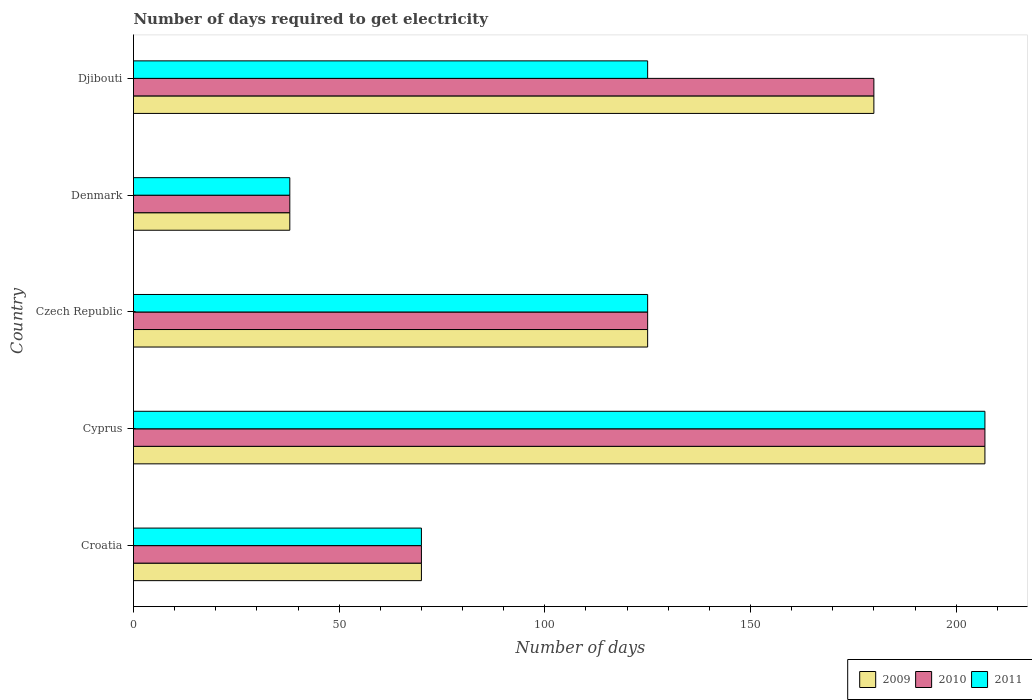How many groups of bars are there?
Provide a succinct answer. 5. How many bars are there on the 5th tick from the top?
Make the answer very short. 3. How many bars are there on the 1st tick from the bottom?
Provide a short and direct response. 3. What is the label of the 4th group of bars from the top?
Your answer should be very brief. Cyprus. What is the number of days required to get electricity in in 2010 in Cyprus?
Your response must be concise. 207. Across all countries, what is the maximum number of days required to get electricity in in 2010?
Make the answer very short. 207. Across all countries, what is the minimum number of days required to get electricity in in 2009?
Ensure brevity in your answer.  38. In which country was the number of days required to get electricity in in 2010 maximum?
Provide a succinct answer. Cyprus. What is the total number of days required to get electricity in in 2009 in the graph?
Make the answer very short. 620. What is the difference between the number of days required to get electricity in in 2009 in Croatia and that in Czech Republic?
Ensure brevity in your answer.  -55. What is the difference between the number of days required to get electricity in in 2010 in Djibouti and the number of days required to get electricity in in 2009 in Cyprus?
Offer a very short reply. -27. What is the average number of days required to get electricity in in 2011 per country?
Make the answer very short. 113. What is the difference between the number of days required to get electricity in in 2011 and number of days required to get electricity in in 2009 in Cyprus?
Give a very brief answer. 0. In how many countries, is the number of days required to get electricity in in 2009 greater than 110 days?
Offer a very short reply. 3. What is the ratio of the number of days required to get electricity in in 2010 in Croatia to that in Djibouti?
Give a very brief answer. 0.39. What is the difference between the highest and the second highest number of days required to get electricity in in 2009?
Keep it short and to the point. 27. What is the difference between the highest and the lowest number of days required to get electricity in in 2009?
Keep it short and to the point. 169. In how many countries, is the number of days required to get electricity in in 2011 greater than the average number of days required to get electricity in in 2011 taken over all countries?
Your answer should be compact. 3. Is the sum of the number of days required to get electricity in in 2011 in Cyprus and Denmark greater than the maximum number of days required to get electricity in in 2010 across all countries?
Make the answer very short. Yes. What does the 2nd bar from the top in Denmark represents?
Your answer should be compact. 2010. Is it the case that in every country, the sum of the number of days required to get electricity in in 2009 and number of days required to get electricity in in 2011 is greater than the number of days required to get electricity in in 2010?
Provide a succinct answer. Yes. How many bars are there?
Make the answer very short. 15. How many countries are there in the graph?
Make the answer very short. 5. Are the values on the major ticks of X-axis written in scientific E-notation?
Offer a terse response. No. Where does the legend appear in the graph?
Your response must be concise. Bottom right. How many legend labels are there?
Provide a short and direct response. 3. What is the title of the graph?
Give a very brief answer. Number of days required to get electricity. What is the label or title of the X-axis?
Keep it short and to the point. Number of days. What is the Number of days in 2010 in Croatia?
Make the answer very short. 70. What is the Number of days of 2011 in Croatia?
Your response must be concise. 70. What is the Number of days of 2009 in Cyprus?
Keep it short and to the point. 207. What is the Number of days in 2010 in Cyprus?
Make the answer very short. 207. What is the Number of days in 2011 in Cyprus?
Your answer should be compact. 207. What is the Number of days in 2009 in Czech Republic?
Give a very brief answer. 125. What is the Number of days in 2010 in Czech Republic?
Ensure brevity in your answer.  125. What is the Number of days of 2011 in Czech Republic?
Provide a short and direct response. 125. What is the Number of days of 2010 in Denmark?
Your answer should be compact. 38. What is the Number of days of 2009 in Djibouti?
Offer a terse response. 180. What is the Number of days of 2010 in Djibouti?
Provide a succinct answer. 180. What is the Number of days of 2011 in Djibouti?
Provide a short and direct response. 125. Across all countries, what is the maximum Number of days in 2009?
Offer a terse response. 207. Across all countries, what is the maximum Number of days of 2010?
Offer a terse response. 207. Across all countries, what is the maximum Number of days of 2011?
Provide a succinct answer. 207. Across all countries, what is the minimum Number of days of 2010?
Make the answer very short. 38. What is the total Number of days of 2009 in the graph?
Offer a terse response. 620. What is the total Number of days of 2010 in the graph?
Your response must be concise. 620. What is the total Number of days of 2011 in the graph?
Your answer should be very brief. 565. What is the difference between the Number of days in 2009 in Croatia and that in Cyprus?
Ensure brevity in your answer.  -137. What is the difference between the Number of days in 2010 in Croatia and that in Cyprus?
Make the answer very short. -137. What is the difference between the Number of days of 2011 in Croatia and that in Cyprus?
Provide a short and direct response. -137. What is the difference between the Number of days in 2009 in Croatia and that in Czech Republic?
Your response must be concise. -55. What is the difference between the Number of days in 2010 in Croatia and that in Czech Republic?
Your answer should be compact. -55. What is the difference between the Number of days of 2011 in Croatia and that in Czech Republic?
Your response must be concise. -55. What is the difference between the Number of days of 2010 in Croatia and that in Denmark?
Offer a very short reply. 32. What is the difference between the Number of days in 2011 in Croatia and that in Denmark?
Give a very brief answer. 32. What is the difference between the Number of days in 2009 in Croatia and that in Djibouti?
Provide a succinct answer. -110. What is the difference between the Number of days in 2010 in Croatia and that in Djibouti?
Offer a terse response. -110. What is the difference between the Number of days in 2011 in Croatia and that in Djibouti?
Provide a short and direct response. -55. What is the difference between the Number of days of 2010 in Cyprus and that in Czech Republic?
Keep it short and to the point. 82. What is the difference between the Number of days in 2009 in Cyprus and that in Denmark?
Give a very brief answer. 169. What is the difference between the Number of days of 2010 in Cyprus and that in Denmark?
Make the answer very short. 169. What is the difference between the Number of days of 2011 in Cyprus and that in Denmark?
Ensure brevity in your answer.  169. What is the difference between the Number of days in 2010 in Czech Republic and that in Denmark?
Offer a very short reply. 87. What is the difference between the Number of days in 2009 in Czech Republic and that in Djibouti?
Keep it short and to the point. -55. What is the difference between the Number of days in 2010 in Czech Republic and that in Djibouti?
Your response must be concise. -55. What is the difference between the Number of days of 2011 in Czech Republic and that in Djibouti?
Your answer should be very brief. 0. What is the difference between the Number of days of 2009 in Denmark and that in Djibouti?
Ensure brevity in your answer.  -142. What is the difference between the Number of days in 2010 in Denmark and that in Djibouti?
Offer a terse response. -142. What is the difference between the Number of days in 2011 in Denmark and that in Djibouti?
Make the answer very short. -87. What is the difference between the Number of days in 2009 in Croatia and the Number of days in 2010 in Cyprus?
Your response must be concise. -137. What is the difference between the Number of days of 2009 in Croatia and the Number of days of 2011 in Cyprus?
Keep it short and to the point. -137. What is the difference between the Number of days of 2010 in Croatia and the Number of days of 2011 in Cyprus?
Offer a terse response. -137. What is the difference between the Number of days of 2009 in Croatia and the Number of days of 2010 in Czech Republic?
Make the answer very short. -55. What is the difference between the Number of days of 2009 in Croatia and the Number of days of 2011 in Czech Republic?
Keep it short and to the point. -55. What is the difference between the Number of days in 2010 in Croatia and the Number of days in 2011 in Czech Republic?
Provide a short and direct response. -55. What is the difference between the Number of days in 2009 in Croatia and the Number of days in 2010 in Djibouti?
Offer a terse response. -110. What is the difference between the Number of days of 2009 in Croatia and the Number of days of 2011 in Djibouti?
Give a very brief answer. -55. What is the difference between the Number of days in 2010 in Croatia and the Number of days in 2011 in Djibouti?
Offer a very short reply. -55. What is the difference between the Number of days in 2009 in Cyprus and the Number of days in 2011 in Czech Republic?
Give a very brief answer. 82. What is the difference between the Number of days of 2010 in Cyprus and the Number of days of 2011 in Czech Republic?
Your answer should be compact. 82. What is the difference between the Number of days of 2009 in Cyprus and the Number of days of 2010 in Denmark?
Give a very brief answer. 169. What is the difference between the Number of days in 2009 in Cyprus and the Number of days in 2011 in Denmark?
Your response must be concise. 169. What is the difference between the Number of days of 2010 in Cyprus and the Number of days of 2011 in Denmark?
Ensure brevity in your answer.  169. What is the difference between the Number of days of 2009 in Cyprus and the Number of days of 2010 in Djibouti?
Keep it short and to the point. 27. What is the difference between the Number of days in 2009 in Cyprus and the Number of days in 2011 in Djibouti?
Give a very brief answer. 82. What is the difference between the Number of days in 2009 in Czech Republic and the Number of days in 2011 in Denmark?
Your answer should be compact. 87. What is the difference between the Number of days in 2010 in Czech Republic and the Number of days in 2011 in Denmark?
Your answer should be compact. 87. What is the difference between the Number of days of 2009 in Czech Republic and the Number of days of 2010 in Djibouti?
Keep it short and to the point. -55. What is the difference between the Number of days of 2010 in Czech Republic and the Number of days of 2011 in Djibouti?
Offer a terse response. 0. What is the difference between the Number of days of 2009 in Denmark and the Number of days of 2010 in Djibouti?
Ensure brevity in your answer.  -142. What is the difference between the Number of days of 2009 in Denmark and the Number of days of 2011 in Djibouti?
Give a very brief answer. -87. What is the difference between the Number of days in 2010 in Denmark and the Number of days in 2011 in Djibouti?
Keep it short and to the point. -87. What is the average Number of days in 2009 per country?
Offer a very short reply. 124. What is the average Number of days in 2010 per country?
Your answer should be compact. 124. What is the average Number of days in 2011 per country?
Keep it short and to the point. 113. What is the difference between the Number of days of 2009 and Number of days of 2010 in Croatia?
Provide a short and direct response. 0. What is the difference between the Number of days of 2010 and Number of days of 2011 in Croatia?
Offer a very short reply. 0. What is the difference between the Number of days of 2010 and Number of days of 2011 in Cyprus?
Provide a short and direct response. 0. What is the difference between the Number of days in 2009 and Number of days in 2011 in Czech Republic?
Offer a terse response. 0. What is the difference between the Number of days in 2009 and Number of days in 2010 in Denmark?
Your answer should be compact. 0. What is the difference between the Number of days of 2009 and Number of days of 2011 in Denmark?
Make the answer very short. 0. What is the difference between the Number of days in 2009 and Number of days in 2010 in Djibouti?
Offer a very short reply. 0. What is the difference between the Number of days of 2010 and Number of days of 2011 in Djibouti?
Make the answer very short. 55. What is the ratio of the Number of days of 2009 in Croatia to that in Cyprus?
Offer a terse response. 0.34. What is the ratio of the Number of days in 2010 in Croatia to that in Cyprus?
Provide a succinct answer. 0.34. What is the ratio of the Number of days in 2011 in Croatia to that in Cyprus?
Your answer should be compact. 0.34. What is the ratio of the Number of days in 2009 in Croatia to that in Czech Republic?
Provide a short and direct response. 0.56. What is the ratio of the Number of days of 2010 in Croatia to that in Czech Republic?
Provide a succinct answer. 0.56. What is the ratio of the Number of days of 2011 in Croatia to that in Czech Republic?
Your answer should be compact. 0.56. What is the ratio of the Number of days of 2009 in Croatia to that in Denmark?
Provide a succinct answer. 1.84. What is the ratio of the Number of days of 2010 in Croatia to that in Denmark?
Ensure brevity in your answer.  1.84. What is the ratio of the Number of days in 2011 in Croatia to that in Denmark?
Your response must be concise. 1.84. What is the ratio of the Number of days in 2009 in Croatia to that in Djibouti?
Offer a very short reply. 0.39. What is the ratio of the Number of days in 2010 in Croatia to that in Djibouti?
Your answer should be compact. 0.39. What is the ratio of the Number of days of 2011 in Croatia to that in Djibouti?
Make the answer very short. 0.56. What is the ratio of the Number of days in 2009 in Cyprus to that in Czech Republic?
Offer a terse response. 1.66. What is the ratio of the Number of days in 2010 in Cyprus to that in Czech Republic?
Make the answer very short. 1.66. What is the ratio of the Number of days in 2011 in Cyprus to that in Czech Republic?
Ensure brevity in your answer.  1.66. What is the ratio of the Number of days in 2009 in Cyprus to that in Denmark?
Provide a short and direct response. 5.45. What is the ratio of the Number of days in 2010 in Cyprus to that in Denmark?
Your response must be concise. 5.45. What is the ratio of the Number of days in 2011 in Cyprus to that in Denmark?
Your response must be concise. 5.45. What is the ratio of the Number of days of 2009 in Cyprus to that in Djibouti?
Give a very brief answer. 1.15. What is the ratio of the Number of days of 2010 in Cyprus to that in Djibouti?
Your answer should be compact. 1.15. What is the ratio of the Number of days of 2011 in Cyprus to that in Djibouti?
Make the answer very short. 1.66. What is the ratio of the Number of days of 2009 in Czech Republic to that in Denmark?
Offer a terse response. 3.29. What is the ratio of the Number of days of 2010 in Czech Republic to that in Denmark?
Your response must be concise. 3.29. What is the ratio of the Number of days of 2011 in Czech Republic to that in Denmark?
Your answer should be very brief. 3.29. What is the ratio of the Number of days of 2009 in Czech Republic to that in Djibouti?
Provide a short and direct response. 0.69. What is the ratio of the Number of days in 2010 in Czech Republic to that in Djibouti?
Your response must be concise. 0.69. What is the ratio of the Number of days of 2009 in Denmark to that in Djibouti?
Your answer should be very brief. 0.21. What is the ratio of the Number of days of 2010 in Denmark to that in Djibouti?
Keep it short and to the point. 0.21. What is the ratio of the Number of days of 2011 in Denmark to that in Djibouti?
Provide a succinct answer. 0.3. What is the difference between the highest and the second highest Number of days in 2009?
Ensure brevity in your answer.  27. What is the difference between the highest and the lowest Number of days in 2009?
Offer a very short reply. 169. What is the difference between the highest and the lowest Number of days in 2010?
Give a very brief answer. 169. What is the difference between the highest and the lowest Number of days of 2011?
Offer a very short reply. 169. 